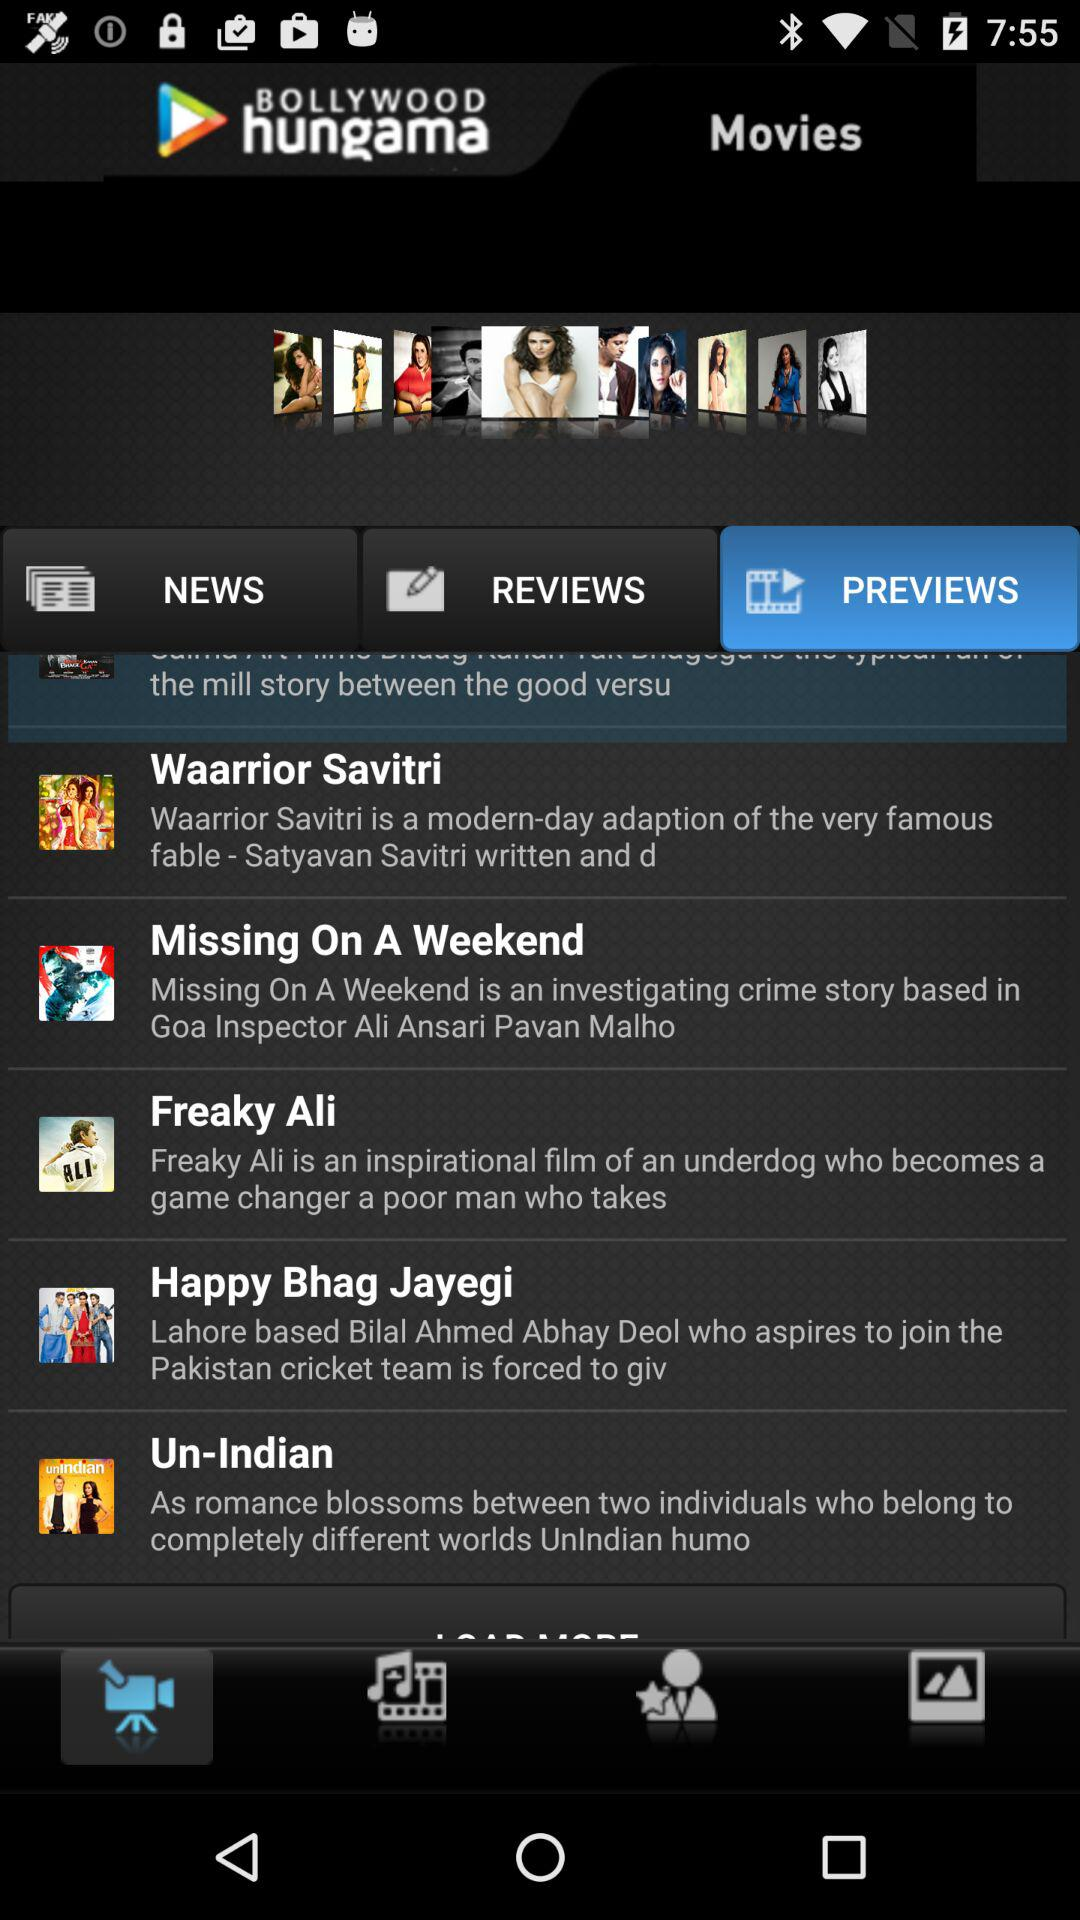Which tab is selected? The selected tab is "PREVIEWS". 